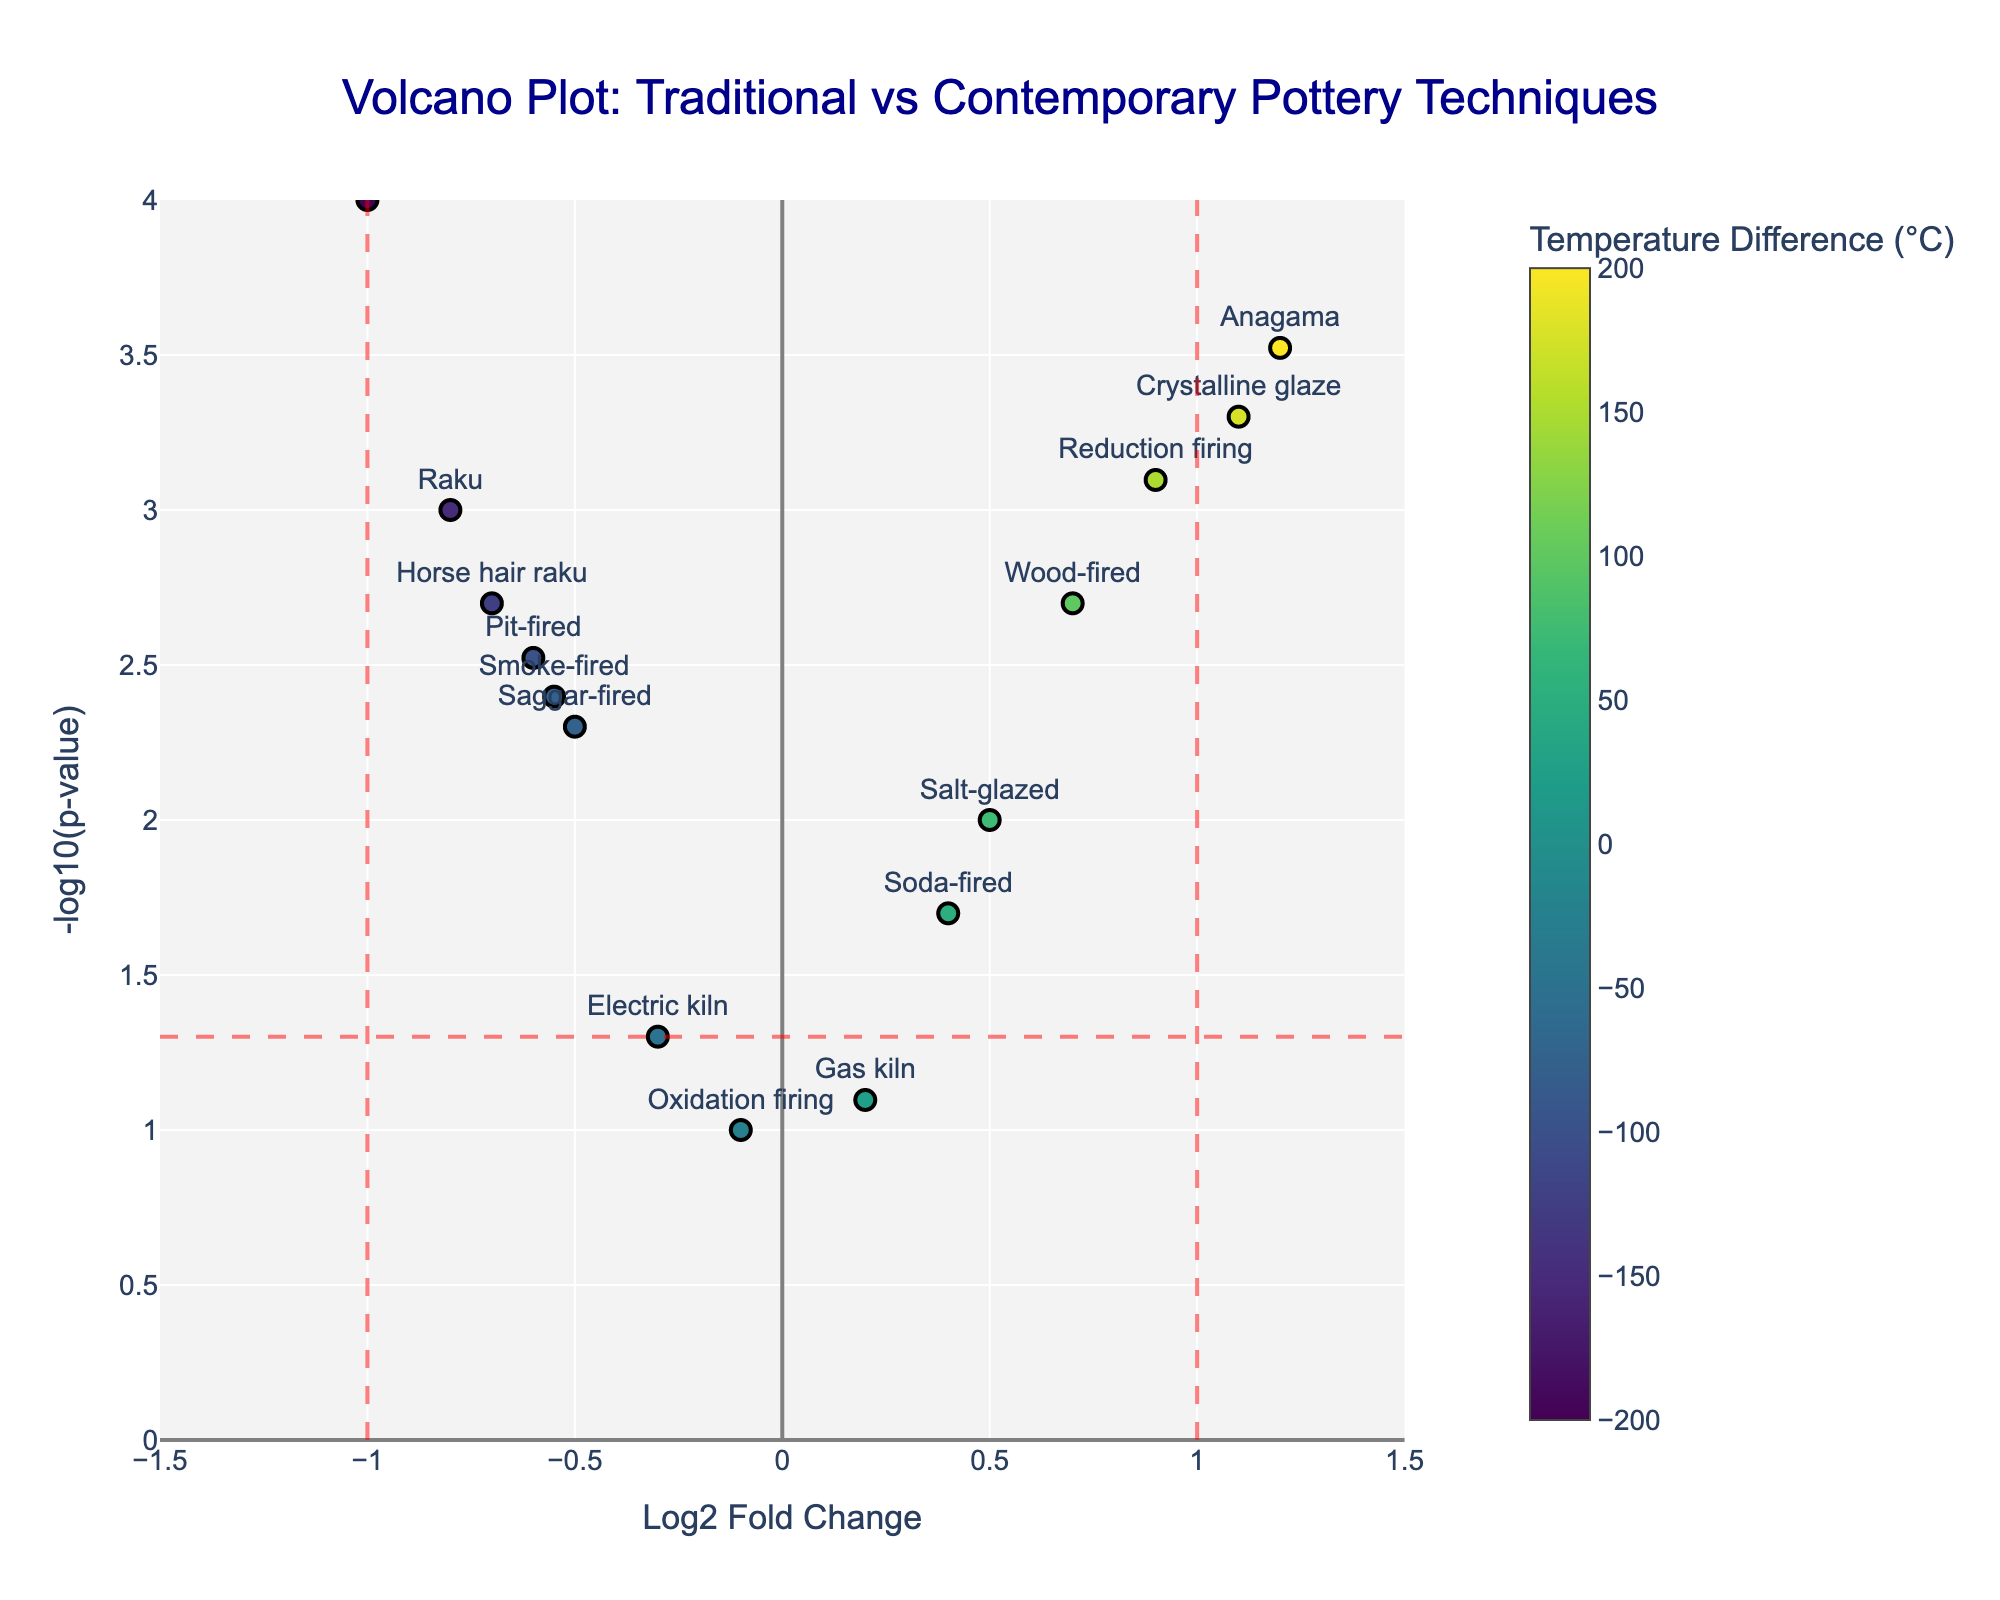What is the title of the plot? The title of a plot is usually found at the top center of the chart. The title in this plot reads "Volcano Plot: Traditional vs Contemporary Pottery Techniques".
Answer: Volcano Plot: Traditional vs Contemporary Pottery Techniques How many data points are there in the plot? By counting the number of distinct markers or labels in the plot, we determine there are 15 techniques being compared.
Answer: 15 Which technique has the highest -log10(p-value)? Looking at the y-axis, the highest point on the plot corresponds to the technique "Low-fire earthenware". Its hover text confirms this.
Answer: Low-fire earthenware What is the log2 Fold Change for Anagama? Find the marker labeled "Anagama" and look at its position on the x-axis; it aligns with the value of 1.2.
Answer: 1.2 Which technique has the most negative log2 fold change? The most negative position on the x-axis corresponds to the technique "Low-fire earthenware", located at -1.0.
Answer: Low-fire earthenware Which technique has the smallest p-value? The smallest p-value will correspond to the highest point on the y-axis. "Low-fire earthenware" is at the topmost position, indicating the smallest p-value.
Answer: Low-fire earthenware How does the temperature difference influence the color of the markers? The color of the markers changes with the temperature difference, with the colorscale indicating the range from blue to yellow. Higher temperature differences are represented by lighter colors and vice versa.
Answer: A gradient from blue to yellow Which techniques show a significant change in temperature and duration, based on the volcano plot? Significant changes are generally indicated by the markers beyond the vertical lines at +-1 log2 fold change and above the horizontal dash line at -log10(0.05). Techniques such as "Anagama," "Reduction firing," "Crystalline glaze," and "Low-fire earthenware" meet this criteria.
Answer: Anagama, Reduction firing, Crystalline glaze, Low-fire earthenware What is common among the firing techniques that fall to the left of the central vertical line? Techniques to the left of the central vertical line (log2 fold change = 0) indicate a decrease in both firing temperature and duration. These techniques include "Raku," "Electric kiln," "Pit-fired," "Saggar-fired," "Horse hair raku," "Smoke-fired," and "Low-fire earthenware."
Answer: Decrease in firing temperature and duration Which data points show a significant positive log2 fold change but non-significant p-value? Data points with positive log2 fold change greater than 1 but below the horizontal significance line (-log10(0.05)) include "Gas kiln" and "Soda-fired."
Answer: Gas kiln, Soda-fired 